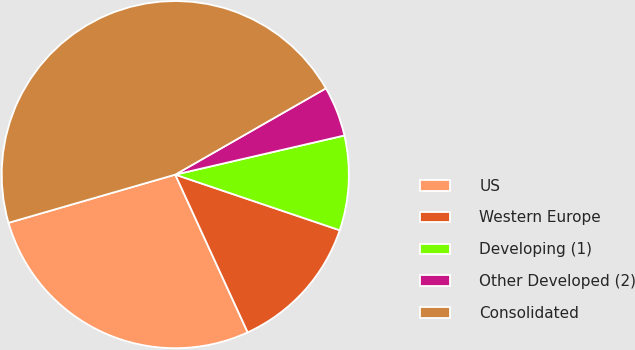<chart> <loc_0><loc_0><loc_500><loc_500><pie_chart><fcel>US<fcel>Western Europe<fcel>Developing (1)<fcel>Other Developed (2)<fcel>Consolidated<nl><fcel>27.37%<fcel>12.96%<fcel>8.81%<fcel>4.66%<fcel>46.2%<nl></chart> 